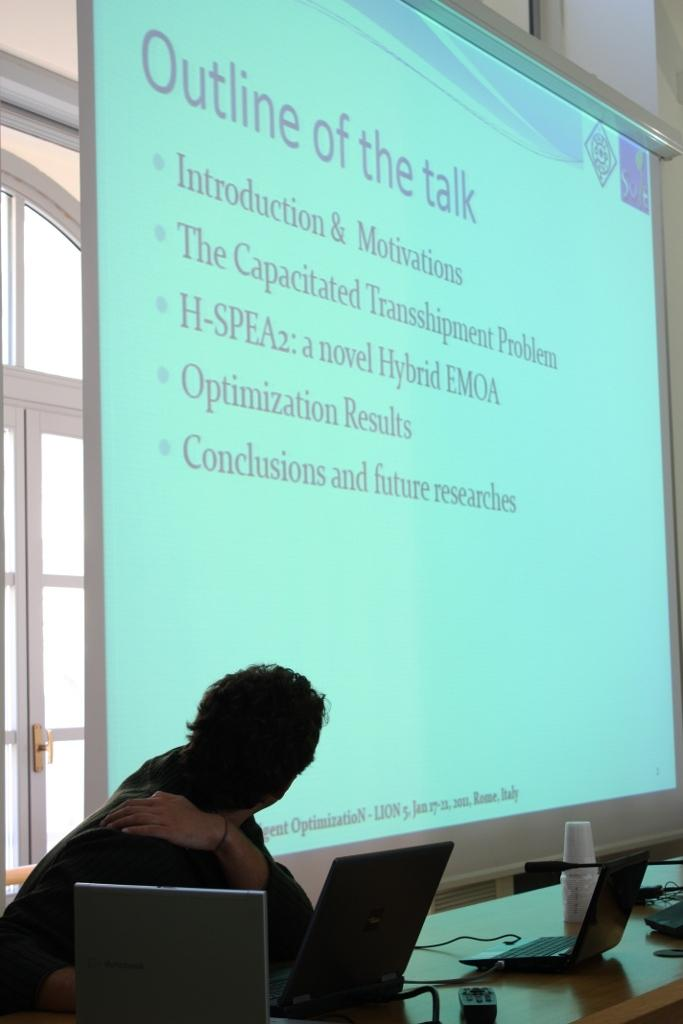<image>
Share a concise interpretation of the image provided. A PowerPoint open on a projector discussing a talk. 